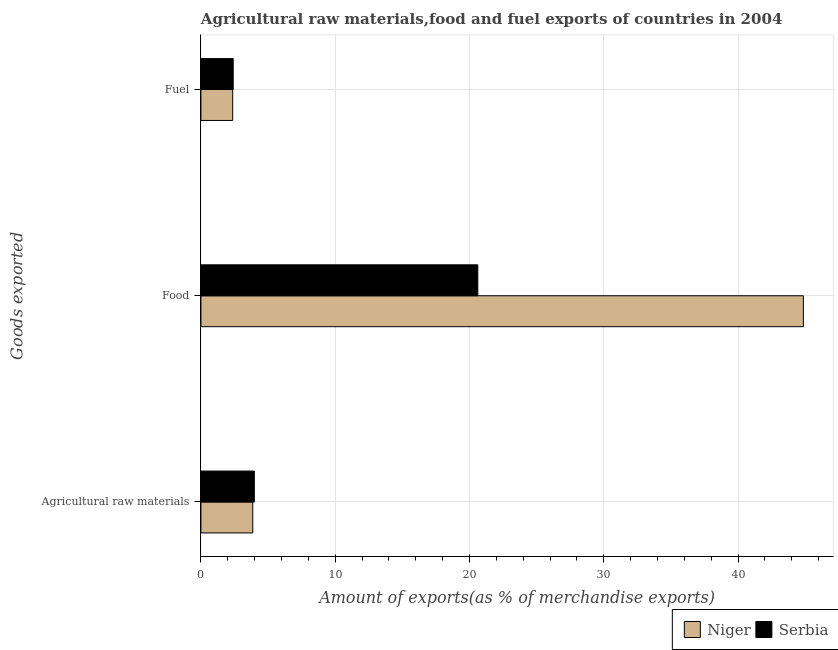How many groups of bars are there?
Offer a very short reply. 3. Are the number of bars per tick equal to the number of legend labels?
Provide a succinct answer. Yes. How many bars are there on the 3rd tick from the top?
Offer a terse response. 2. What is the label of the 3rd group of bars from the top?
Make the answer very short. Agricultural raw materials. What is the percentage of food exports in Serbia?
Keep it short and to the point. 20.62. Across all countries, what is the maximum percentage of food exports?
Give a very brief answer. 44.87. Across all countries, what is the minimum percentage of food exports?
Keep it short and to the point. 20.62. In which country was the percentage of food exports maximum?
Make the answer very short. Niger. In which country was the percentage of raw materials exports minimum?
Provide a succinct answer. Niger. What is the total percentage of food exports in the graph?
Offer a very short reply. 65.49. What is the difference between the percentage of fuel exports in Niger and that in Serbia?
Offer a terse response. -0.04. What is the difference between the percentage of food exports in Serbia and the percentage of fuel exports in Niger?
Your answer should be very brief. 18.25. What is the average percentage of food exports per country?
Your answer should be compact. 32.74. What is the difference between the percentage of raw materials exports and percentage of fuel exports in Niger?
Offer a terse response. 1.5. In how many countries, is the percentage of food exports greater than 12 %?
Your answer should be very brief. 2. What is the ratio of the percentage of fuel exports in Serbia to that in Niger?
Ensure brevity in your answer.  1.02. What is the difference between the highest and the second highest percentage of raw materials exports?
Give a very brief answer. 0.12. What is the difference between the highest and the lowest percentage of fuel exports?
Provide a succinct answer. 0.04. Is the sum of the percentage of food exports in Serbia and Niger greater than the maximum percentage of fuel exports across all countries?
Keep it short and to the point. Yes. What does the 2nd bar from the top in Agricultural raw materials represents?
Keep it short and to the point. Niger. What does the 1st bar from the bottom in Fuel represents?
Make the answer very short. Niger. How many bars are there?
Offer a terse response. 6. What is the difference between two consecutive major ticks on the X-axis?
Offer a terse response. 10. Are the values on the major ticks of X-axis written in scientific E-notation?
Give a very brief answer. No. Does the graph contain any zero values?
Give a very brief answer. No. Does the graph contain grids?
Make the answer very short. Yes. What is the title of the graph?
Ensure brevity in your answer.  Agricultural raw materials,food and fuel exports of countries in 2004. What is the label or title of the X-axis?
Offer a terse response. Amount of exports(as % of merchandise exports). What is the label or title of the Y-axis?
Provide a succinct answer. Goods exported. What is the Amount of exports(as % of merchandise exports) of Niger in Agricultural raw materials?
Your response must be concise. 3.86. What is the Amount of exports(as % of merchandise exports) of Serbia in Agricultural raw materials?
Provide a succinct answer. 3.98. What is the Amount of exports(as % of merchandise exports) in Niger in Food?
Your answer should be compact. 44.87. What is the Amount of exports(as % of merchandise exports) in Serbia in Food?
Ensure brevity in your answer.  20.62. What is the Amount of exports(as % of merchandise exports) in Niger in Fuel?
Your answer should be very brief. 2.37. What is the Amount of exports(as % of merchandise exports) of Serbia in Fuel?
Give a very brief answer. 2.4. Across all Goods exported, what is the maximum Amount of exports(as % of merchandise exports) in Niger?
Offer a terse response. 44.87. Across all Goods exported, what is the maximum Amount of exports(as % of merchandise exports) of Serbia?
Your answer should be compact. 20.62. Across all Goods exported, what is the minimum Amount of exports(as % of merchandise exports) of Niger?
Provide a short and direct response. 2.37. Across all Goods exported, what is the minimum Amount of exports(as % of merchandise exports) in Serbia?
Your response must be concise. 2.4. What is the total Amount of exports(as % of merchandise exports) in Niger in the graph?
Provide a short and direct response. 51.1. What is the total Amount of exports(as % of merchandise exports) of Serbia in the graph?
Offer a terse response. 27.01. What is the difference between the Amount of exports(as % of merchandise exports) in Niger in Agricultural raw materials and that in Food?
Provide a short and direct response. -41.01. What is the difference between the Amount of exports(as % of merchandise exports) in Serbia in Agricultural raw materials and that in Food?
Your response must be concise. -16.64. What is the difference between the Amount of exports(as % of merchandise exports) of Niger in Agricultural raw materials and that in Fuel?
Give a very brief answer. 1.5. What is the difference between the Amount of exports(as % of merchandise exports) of Serbia in Agricultural raw materials and that in Fuel?
Offer a very short reply. 1.57. What is the difference between the Amount of exports(as % of merchandise exports) of Niger in Food and that in Fuel?
Keep it short and to the point. 42.5. What is the difference between the Amount of exports(as % of merchandise exports) of Serbia in Food and that in Fuel?
Your response must be concise. 18.22. What is the difference between the Amount of exports(as % of merchandise exports) in Niger in Agricultural raw materials and the Amount of exports(as % of merchandise exports) in Serbia in Food?
Provide a short and direct response. -16.76. What is the difference between the Amount of exports(as % of merchandise exports) of Niger in Agricultural raw materials and the Amount of exports(as % of merchandise exports) of Serbia in Fuel?
Ensure brevity in your answer.  1.46. What is the difference between the Amount of exports(as % of merchandise exports) of Niger in Food and the Amount of exports(as % of merchandise exports) of Serbia in Fuel?
Make the answer very short. 42.46. What is the average Amount of exports(as % of merchandise exports) in Niger per Goods exported?
Your response must be concise. 17.03. What is the average Amount of exports(as % of merchandise exports) of Serbia per Goods exported?
Give a very brief answer. 9. What is the difference between the Amount of exports(as % of merchandise exports) of Niger and Amount of exports(as % of merchandise exports) of Serbia in Agricultural raw materials?
Make the answer very short. -0.12. What is the difference between the Amount of exports(as % of merchandise exports) in Niger and Amount of exports(as % of merchandise exports) in Serbia in Food?
Your answer should be compact. 24.25. What is the difference between the Amount of exports(as % of merchandise exports) in Niger and Amount of exports(as % of merchandise exports) in Serbia in Fuel?
Offer a terse response. -0.04. What is the ratio of the Amount of exports(as % of merchandise exports) in Niger in Agricultural raw materials to that in Food?
Provide a short and direct response. 0.09. What is the ratio of the Amount of exports(as % of merchandise exports) in Serbia in Agricultural raw materials to that in Food?
Give a very brief answer. 0.19. What is the ratio of the Amount of exports(as % of merchandise exports) of Niger in Agricultural raw materials to that in Fuel?
Make the answer very short. 1.63. What is the ratio of the Amount of exports(as % of merchandise exports) of Serbia in Agricultural raw materials to that in Fuel?
Give a very brief answer. 1.66. What is the ratio of the Amount of exports(as % of merchandise exports) of Niger in Food to that in Fuel?
Make the answer very short. 18.96. What is the ratio of the Amount of exports(as % of merchandise exports) of Serbia in Food to that in Fuel?
Ensure brevity in your answer.  8.58. What is the difference between the highest and the second highest Amount of exports(as % of merchandise exports) of Niger?
Your response must be concise. 41.01. What is the difference between the highest and the second highest Amount of exports(as % of merchandise exports) of Serbia?
Your response must be concise. 16.64. What is the difference between the highest and the lowest Amount of exports(as % of merchandise exports) in Niger?
Give a very brief answer. 42.5. What is the difference between the highest and the lowest Amount of exports(as % of merchandise exports) of Serbia?
Offer a terse response. 18.22. 